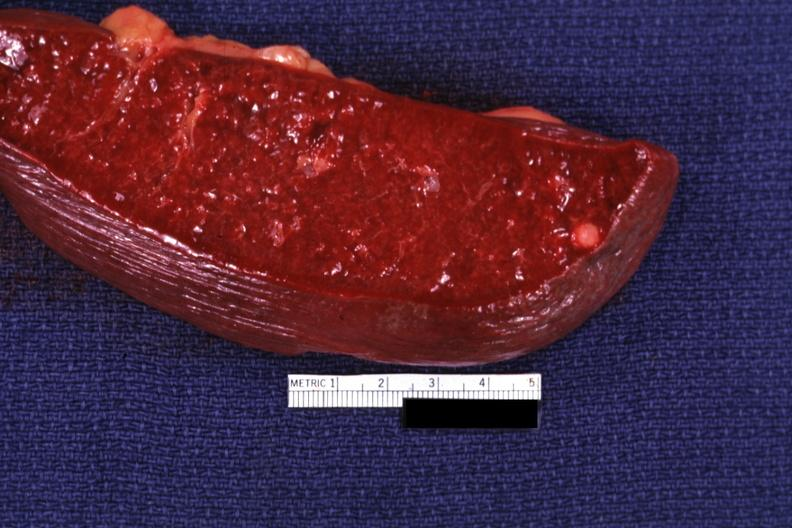does this image show cut surface with typical healed granuloma?
Answer the question using a single word or phrase. Yes 